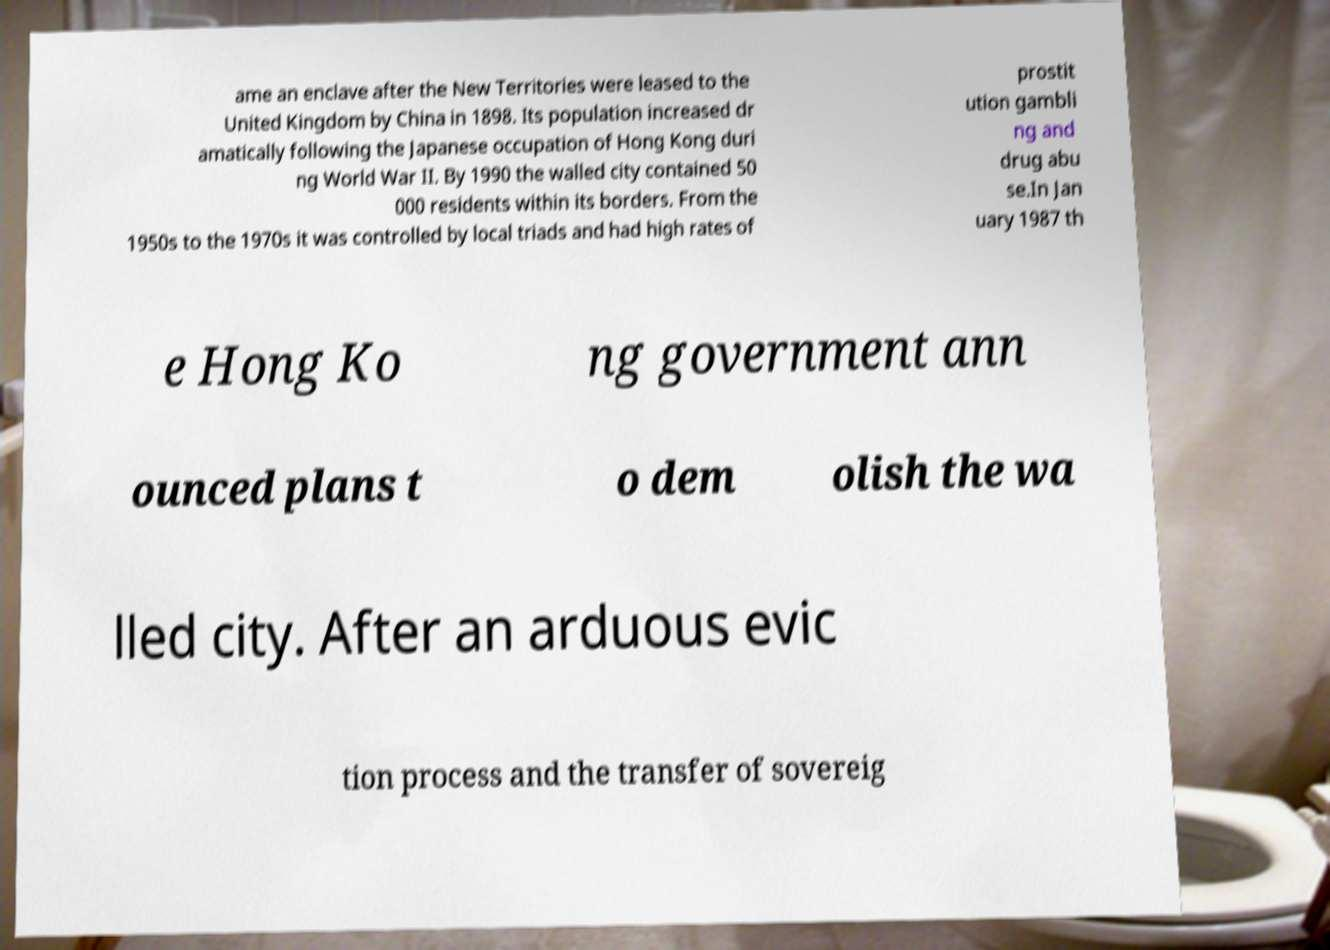There's text embedded in this image that I need extracted. Can you transcribe it verbatim? ame an enclave after the New Territories were leased to the United Kingdom by China in 1898. Its population increased dr amatically following the Japanese occupation of Hong Kong duri ng World War II. By 1990 the walled city contained 50 000 residents within its borders. From the 1950s to the 1970s it was controlled by local triads and had high rates of prostit ution gambli ng and drug abu se.In Jan uary 1987 th e Hong Ko ng government ann ounced plans t o dem olish the wa lled city. After an arduous evic tion process and the transfer of sovereig 